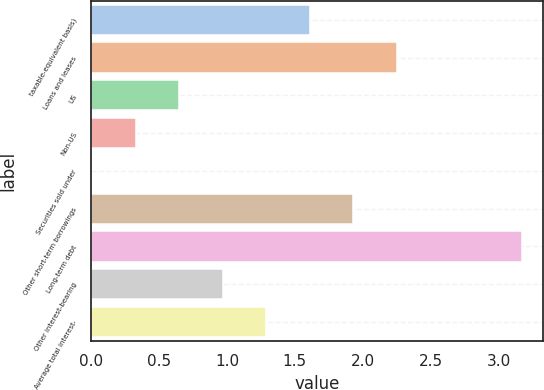Convert chart. <chart><loc_0><loc_0><loc_500><loc_500><bar_chart><fcel>taxable-equivalent basis)<fcel>Loans and leases<fcel>US<fcel>Non-US<fcel>Securities sold under<fcel>Other short-term borrowings<fcel>Long-term debt<fcel>Other interest-bearing<fcel>Average total interest-<nl><fcel>1.61<fcel>2.25<fcel>0.65<fcel>0.33<fcel>0.01<fcel>1.93<fcel>3.17<fcel>0.97<fcel>1.29<nl></chart> 